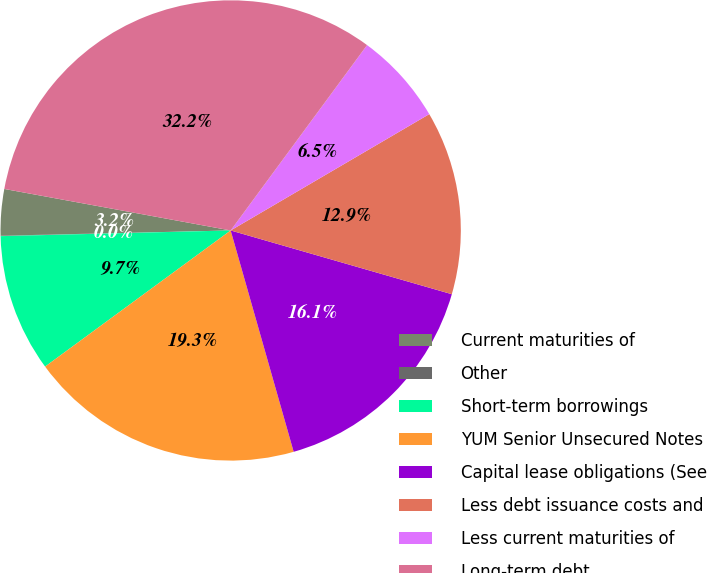Convert chart to OTSL. <chart><loc_0><loc_0><loc_500><loc_500><pie_chart><fcel>Current maturities of<fcel>Other<fcel>Short-term borrowings<fcel>YUM Senior Unsecured Notes<fcel>Capital lease obligations (See<fcel>Less debt issuance costs and<fcel>Less current maturities of<fcel>Long-term debt<nl><fcel>3.25%<fcel>0.03%<fcel>9.68%<fcel>19.34%<fcel>16.12%<fcel>12.9%<fcel>6.47%<fcel>32.21%<nl></chart> 